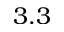<formula> <loc_0><loc_0><loc_500><loc_500>3 . 3</formula> 